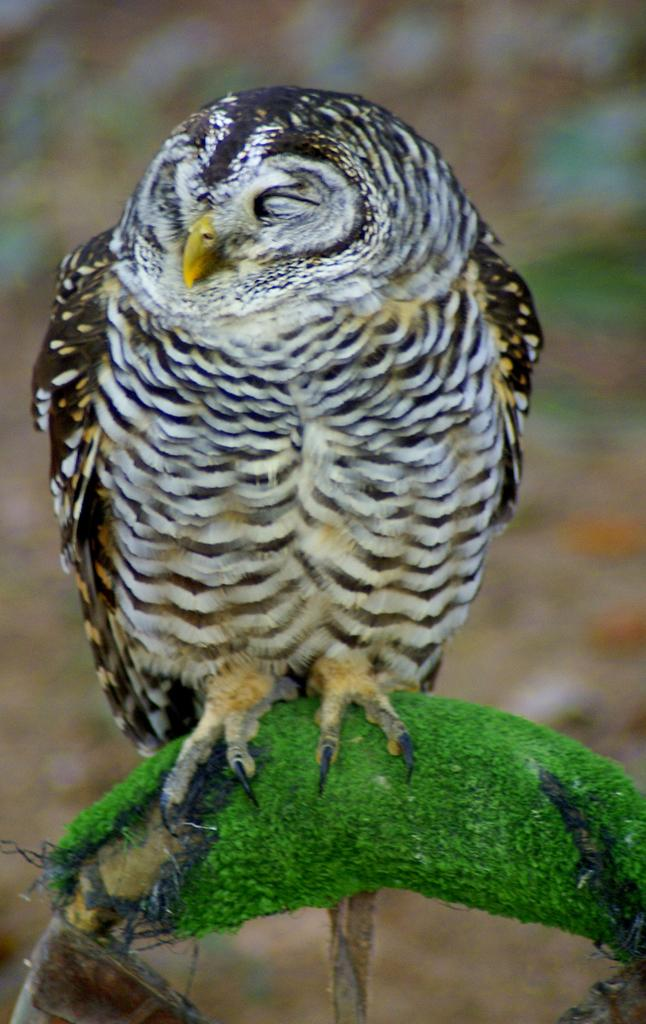What animal is in the image? There is an owl in the image. Where is the owl located? The owl is on a stem in the image. Can you describe the background of the image? The background of the image is not clear. What type of argument is the owl having with the branch in the image? There is no branch present in the image, and the owl is not having an argument. 